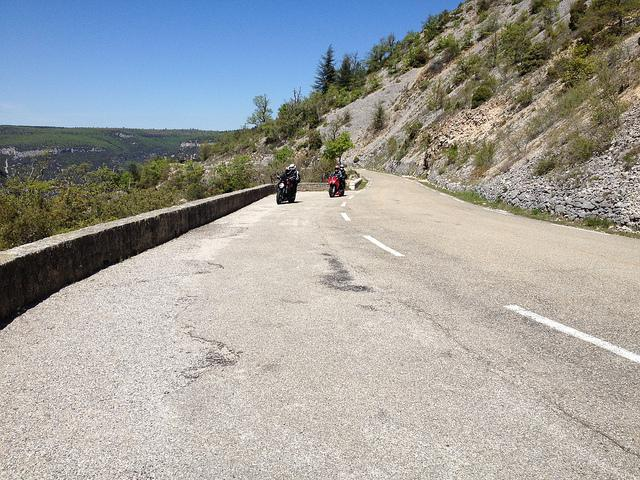What color is the vehicle on the right? red 